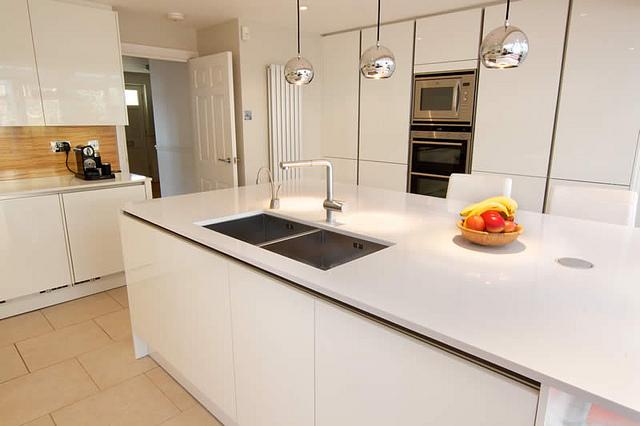What is in the kitchen?
Be succinct. Fruit. How many skylights can be seen?
Keep it brief. 0. Where does the open doorway lead to?
Short answer required. Front door. Is the kitchen empty?
Give a very brief answer. Yes. Is this a bathroom?
Give a very brief answer. No. Where is the iPod?
Short answer required. Counter. Is there an oven in this kitchen?
Be succinct. Yes. What room is this?
Give a very brief answer. Kitchen. What is the red thing in the background?
Give a very brief answer. Apple. Which room is this?
Answer briefly. Kitchen. 